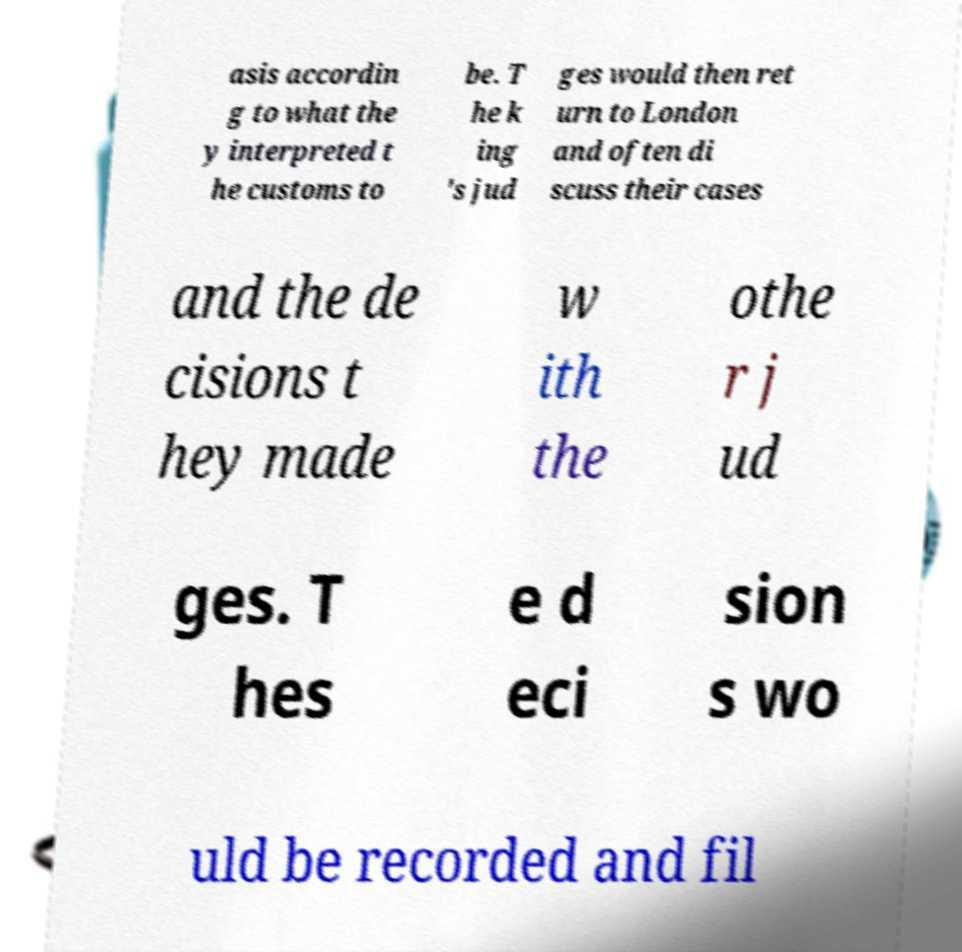Could you assist in decoding the text presented in this image and type it out clearly? asis accordin g to what the y interpreted t he customs to be. T he k ing 's jud ges would then ret urn to London and often di scuss their cases and the de cisions t hey made w ith the othe r j ud ges. T hes e d eci sion s wo uld be recorded and fil 